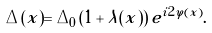<formula> <loc_0><loc_0><loc_500><loc_500>\Delta ( x ) = \Delta _ { 0 } \left ( 1 + \lambda ( x ) \right ) e ^ { i 2 \varphi ( x ) } .</formula> 